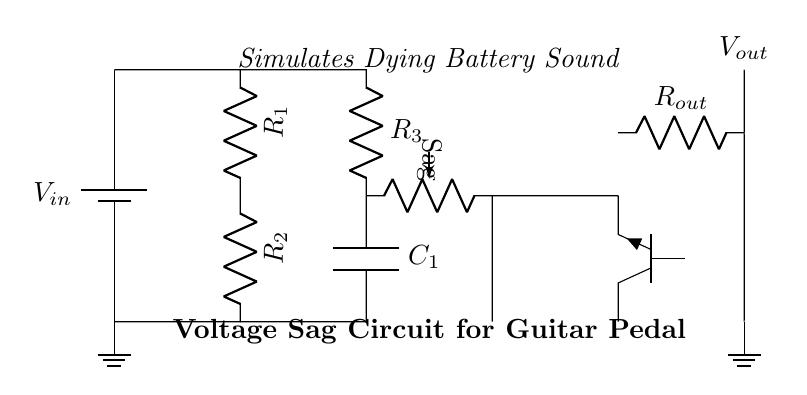What is the function of R1? R1 serves as part of the main signal path to drop voltage and limit current within the circuit. It is critical for controlling the overall impedance of the circuit.
Answer: Resistor What component simulates the dying battery sound? The circuit uses the potentiometer labeled "Sag" to adjust the voltage sag effect, creating a sound reminiscent of a dying battery in guitar pedals.
Answer: Potentiometer How many resistors are in this circuit? There are three resistors in the circuit, R1, R2, and R3, which are essential for controlling the circuit’s behavior and voltage levels.
Answer: Three What role does the capacitor play in this circuit? The capacitor, labeled C1, helps smooth out the voltage fluctuations caused by the sag effect and stores energy, contributing to the circuit's sound dynamics.
Answer: Energy storage What type of transistor is used? The circuit employs an NPN transistor labeled npn, which acts as a current amplifier and is necessary for the desired effects on the output signal.
Answer: NPN What is the purpose of Rout? Rout serves as a load resistor in the output stage, affecting the output voltage and the overall signal characteristics tied to the guitar pedal's operation.
Answer: Load resistor What does the sag control do? The sag control allows the user to adjust the degree of voltage drop in the circuit, influencing the tonal quality and dynamics of the guitar sound by simulating less voltage from a battery.
Answer: Adjusts voltage drop 